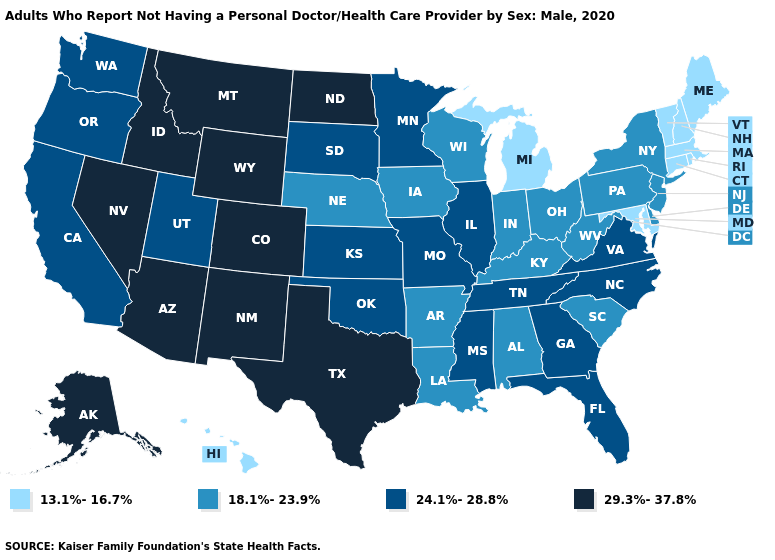What is the value of New Jersey?
Concise answer only. 18.1%-23.9%. Does New York have the lowest value in the Northeast?
Answer briefly. No. Name the states that have a value in the range 29.3%-37.8%?
Answer briefly. Alaska, Arizona, Colorado, Idaho, Montana, Nevada, New Mexico, North Dakota, Texas, Wyoming. Which states hav the highest value in the Northeast?
Write a very short answer. New Jersey, New York, Pennsylvania. Does South Dakota have the same value as New Jersey?
Quick response, please. No. Does the map have missing data?
Be succinct. No. Among the states that border Virginia , does West Virginia have the lowest value?
Write a very short answer. No. Does Florida have a higher value than Ohio?
Concise answer only. Yes. Does the first symbol in the legend represent the smallest category?
Short answer required. Yes. Name the states that have a value in the range 29.3%-37.8%?
Short answer required. Alaska, Arizona, Colorado, Idaho, Montana, Nevada, New Mexico, North Dakota, Texas, Wyoming. What is the value of Utah?
Quick response, please. 24.1%-28.8%. Name the states that have a value in the range 13.1%-16.7%?
Concise answer only. Connecticut, Hawaii, Maine, Maryland, Massachusetts, Michigan, New Hampshire, Rhode Island, Vermont. Which states have the lowest value in the USA?
Give a very brief answer. Connecticut, Hawaii, Maine, Maryland, Massachusetts, Michigan, New Hampshire, Rhode Island, Vermont. What is the value of Illinois?
Short answer required. 24.1%-28.8%. 